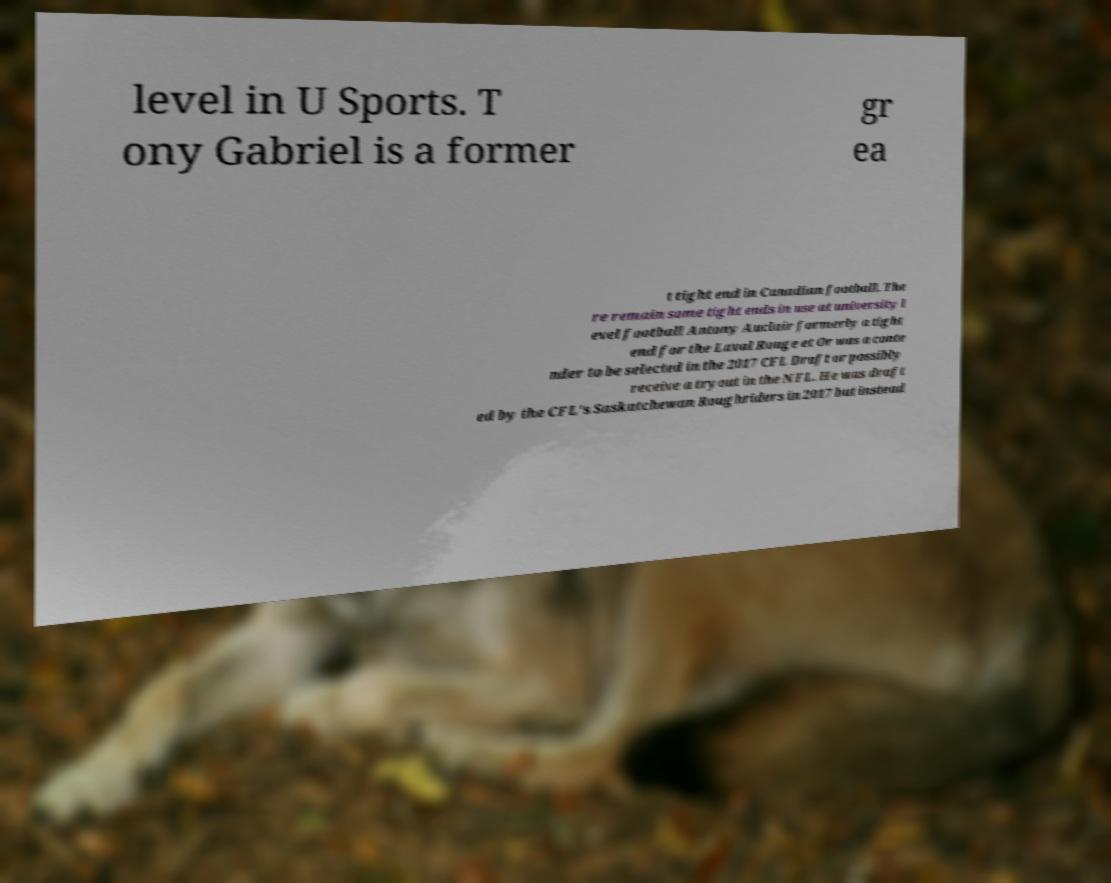Please identify and transcribe the text found in this image. level in U Sports. T ony Gabriel is a former gr ea t tight end in Canadian football. The re remain some tight ends in use at university l evel football Antony Auclair formerly a tight end for the Laval Rouge et Or was a conte nder to be selected in the 2017 CFL Draft or possibly receive a tryout in the NFL. He was draft ed by the CFL's Saskatchewan Roughriders in 2017 but instead 